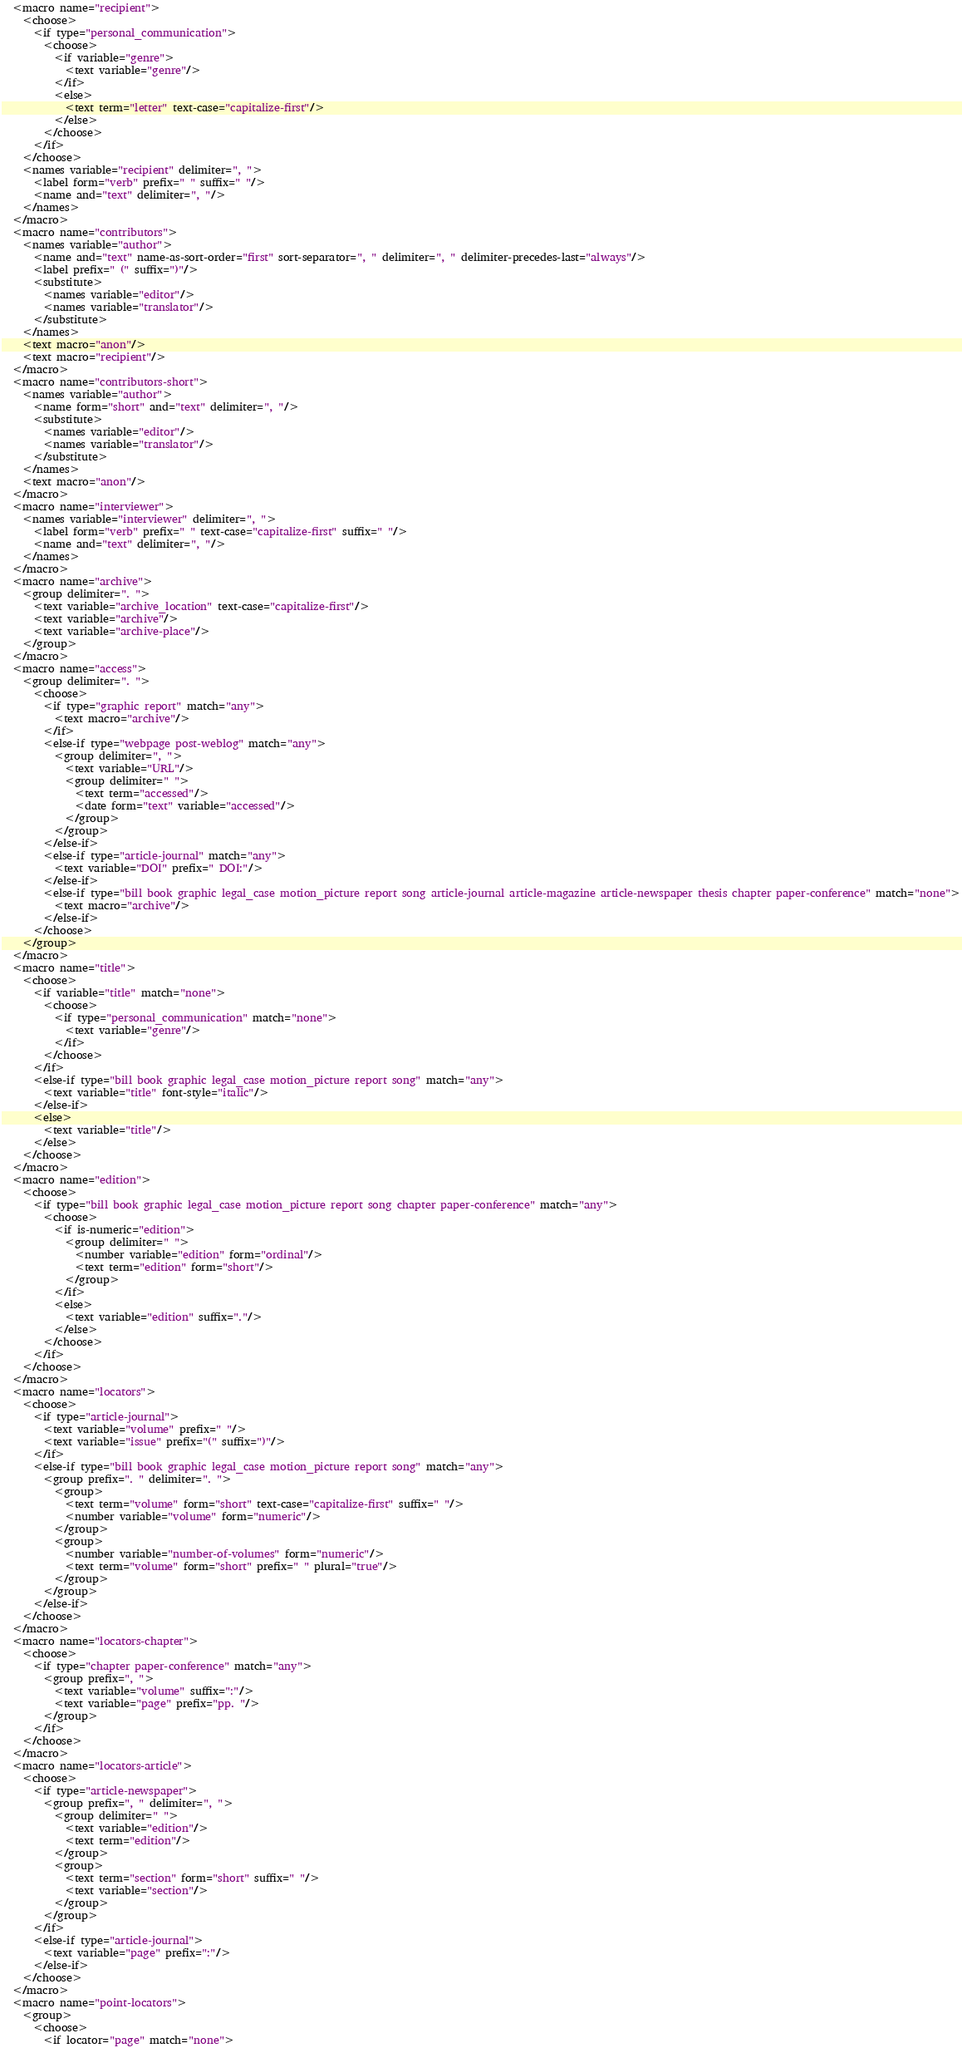Convert code to text. <code><loc_0><loc_0><loc_500><loc_500><_XML_>  <macro name="recipient">
    <choose>
      <if type="personal_communication">
        <choose>
          <if variable="genre">
            <text variable="genre"/>
          </if>
          <else>
            <text term="letter" text-case="capitalize-first"/>
          </else>
        </choose>
      </if>
    </choose>
    <names variable="recipient" delimiter=", ">
      <label form="verb" prefix=" " suffix=" "/>
      <name and="text" delimiter=", "/>
    </names>
  </macro>
  <macro name="contributors">
    <names variable="author">
      <name and="text" name-as-sort-order="first" sort-separator=", " delimiter=", " delimiter-precedes-last="always"/>
      <label prefix=" (" suffix=")"/>
      <substitute>
        <names variable="editor"/>
        <names variable="translator"/>
      </substitute>
    </names>
    <text macro="anon"/>
    <text macro="recipient"/>
  </macro>
  <macro name="contributors-short">
    <names variable="author">
      <name form="short" and="text" delimiter=", "/>
      <substitute>
        <names variable="editor"/>
        <names variable="translator"/>
      </substitute>
    </names>
    <text macro="anon"/>
  </macro>
  <macro name="interviewer">
    <names variable="interviewer" delimiter=", ">
      <label form="verb" prefix=" " text-case="capitalize-first" suffix=" "/>
      <name and="text" delimiter=", "/>
    </names>
  </macro>
  <macro name="archive">
    <group delimiter=". ">
      <text variable="archive_location" text-case="capitalize-first"/>
      <text variable="archive"/>
      <text variable="archive-place"/>
    </group>
  </macro>
  <macro name="access">
    <group delimiter=". ">
      <choose>
        <if type="graphic report" match="any">
          <text macro="archive"/>
        </if>
        <else-if type="webpage post-weblog" match="any">
          <group delimiter=", ">
            <text variable="URL"/>
            <group delimiter=" ">
              <text term="accessed"/>
              <date form="text" variable="accessed"/>
            </group>
          </group>
        </else-if>
        <else-if type="article-journal" match="any">
          <text variable="DOI" prefix=" DOI:"/>
        </else-if>
        <else-if type="bill book graphic legal_case motion_picture report song article-journal article-magazine article-newspaper thesis chapter paper-conference" match="none">
          <text macro="archive"/>
        </else-if>
      </choose>
    </group>
  </macro>
  <macro name="title">
    <choose>
      <if variable="title" match="none">
        <choose>
          <if type="personal_communication" match="none">
            <text variable="genre"/>
          </if>
        </choose>
      </if>
      <else-if type="bill book graphic legal_case motion_picture report song" match="any">
        <text variable="title" font-style="italic"/>
      </else-if>
      <else>
        <text variable="title"/>
      </else>
    </choose>
  </macro>
  <macro name="edition">
    <choose>
      <if type="bill book graphic legal_case motion_picture report song chapter paper-conference" match="any">
        <choose>
          <if is-numeric="edition">
            <group delimiter=" ">
              <number variable="edition" form="ordinal"/>
              <text term="edition" form="short"/>
            </group>
          </if>
          <else>
            <text variable="edition" suffix="."/>
          </else>
        </choose>
      </if>
    </choose>
  </macro>
  <macro name="locators">
    <choose>
      <if type="article-journal">
        <text variable="volume" prefix=" "/>
        <text variable="issue" prefix="(" suffix=")"/>
      </if>
      <else-if type="bill book graphic legal_case motion_picture report song" match="any">
        <group prefix=". " delimiter=". ">
          <group>
            <text term="volume" form="short" text-case="capitalize-first" suffix=" "/>
            <number variable="volume" form="numeric"/>
          </group>
          <group>
            <number variable="number-of-volumes" form="numeric"/>
            <text term="volume" form="short" prefix=" " plural="true"/>
          </group>
        </group>
      </else-if>
    </choose>
  </macro>
  <macro name="locators-chapter">
    <choose>
      <if type="chapter paper-conference" match="any">
        <group prefix=", ">
          <text variable="volume" suffix=":"/>
          <text variable="page" prefix="pp. "/>
        </group>
      </if>
    </choose>
  </macro>
  <macro name="locators-article">
    <choose>
      <if type="article-newspaper">
        <group prefix=", " delimiter=", ">
          <group delimiter=" ">
            <text variable="edition"/>
            <text term="edition"/>
          </group>
          <group>
            <text term="section" form="short" suffix=" "/>
            <text variable="section"/>
          </group>
        </group>
      </if>
      <else-if type="article-journal">
        <text variable="page" prefix=":"/>
      </else-if>
    </choose>
  </macro>
  <macro name="point-locators">
    <group>
      <choose>
        <if locator="page" match="none"></code> 